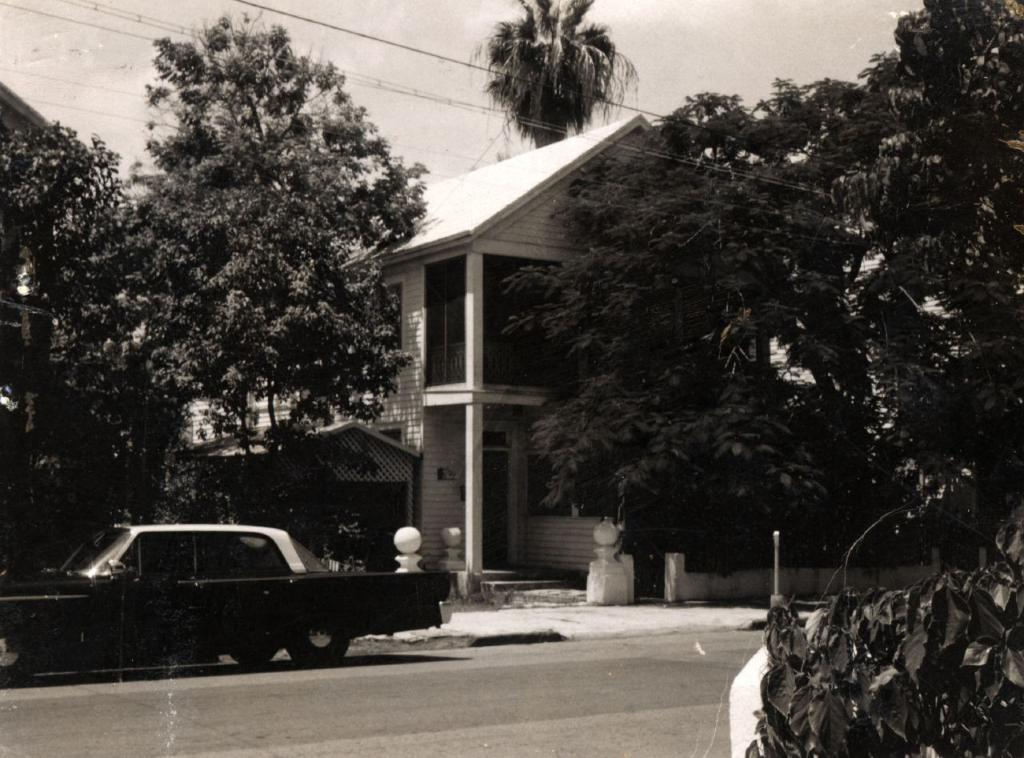What is the main subject of the image? The main subject of the image is a car on the road. What else can be seen in the image besides the car? There are houses, trees, wires, leaves, and the sky visible in the image. Can you describe the houses in the image? The houses are part of the background and are located near the road. What type of vegetation is present in the image? Trees and leaves are present in the image. What type of appliance is being used by the expert in the image? There is no expert or appliance present in the image. What type of needle is being used by the person in the image? There is no person or needle present in the image. 